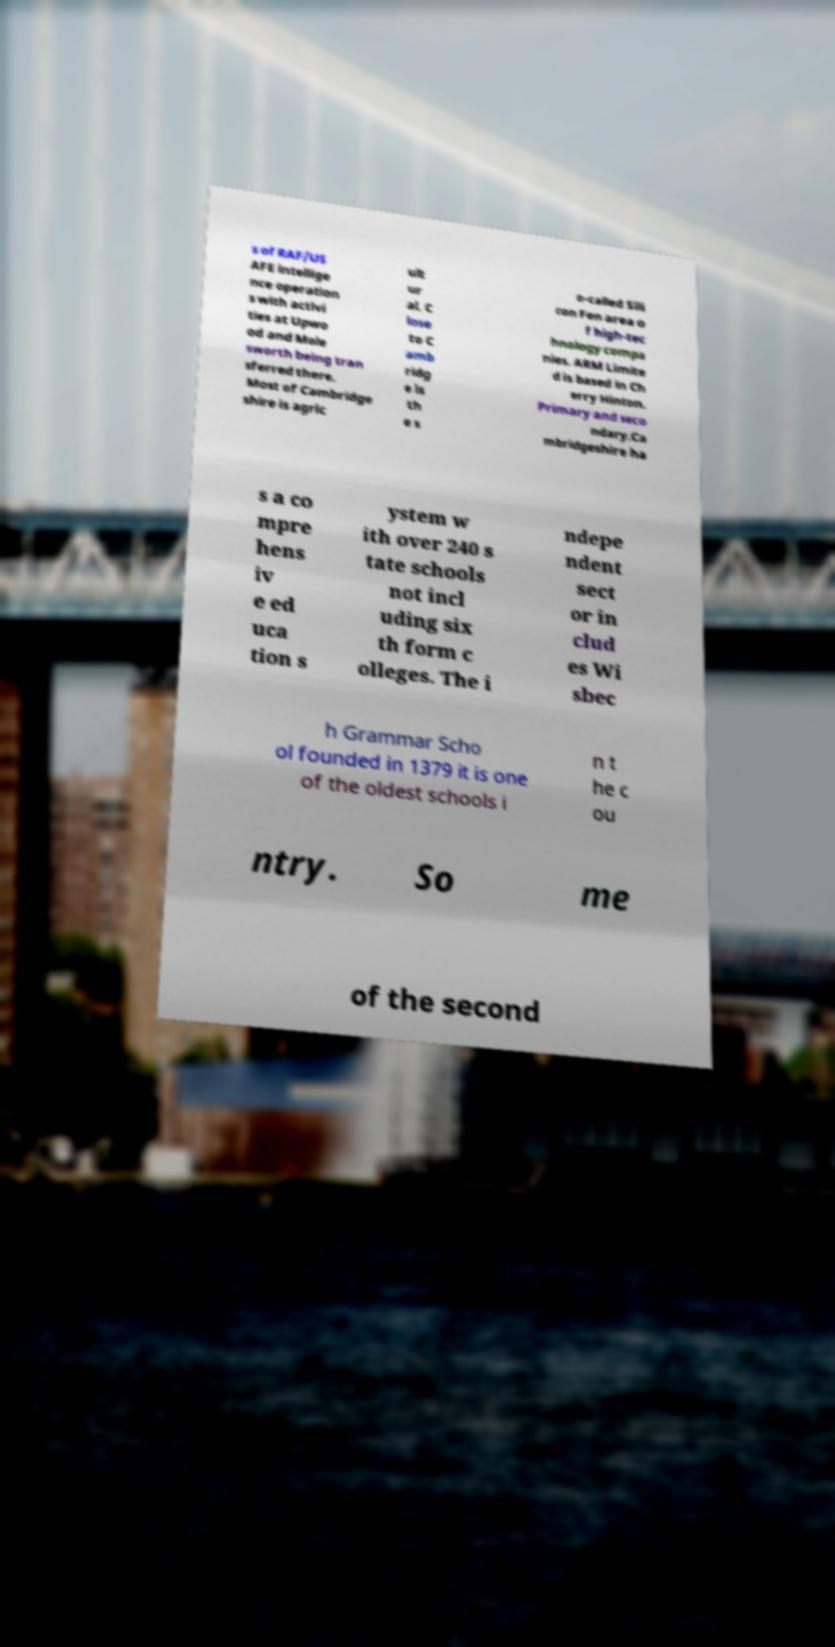I need the written content from this picture converted into text. Can you do that? s of RAF/US AFE intellige nce operation s with activi ties at Upwo od and Mole sworth being tran sferred there. Most of Cambridge shire is agric ult ur al. C lose to C amb ridg e is th e s o-called Sili con Fen area o f high-tec hnology compa nies. ARM Limite d is based in Ch erry Hinton. Primary and seco ndary.Ca mbridgeshire ha s a co mpre hens iv e ed uca tion s ystem w ith over 240 s tate schools not incl uding six th form c olleges. The i ndepe ndent sect or in clud es Wi sbec h Grammar Scho ol founded in 1379 it is one of the oldest schools i n t he c ou ntry. So me of the second 